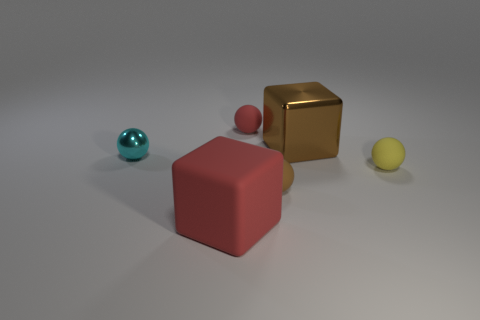Is the number of red spheres to the left of the tiny cyan shiny thing less than the number of metal blocks in front of the tiny red matte object?
Offer a terse response. Yes. What is the big object behind the yellow rubber ball made of?
Provide a short and direct response. Metal. Are there any rubber things behind the red matte sphere?
Your answer should be very brief. No. What is the shape of the big brown thing?
Make the answer very short. Cube. What number of things are rubber objects in front of the small red matte thing or big rubber objects?
Offer a very short reply. 3. How many other things are there of the same color as the big rubber cube?
Offer a very short reply. 1. Does the large matte thing have the same color as the rubber sphere left of the brown sphere?
Your answer should be very brief. Yes. There is a tiny shiny object that is the same shape as the small brown matte thing; what color is it?
Provide a short and direct response. Cyan. Is the tiny cyan sphere made of the same material as the large red thing that is in front of the large shiny thing?
Offer a terse response. No. What is the color of the metallic ball?
Offer a very short reply. Cyan. 